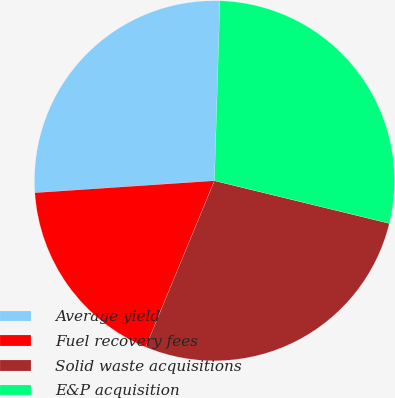<chart> <loc_0><loc_0><loc_500><loc_500><pie_chart><fcel>Average yield<fcel>Fuel recovery fees<fcel>Solid waste acquisitions<fcel>E&P acquisition<nl><fcel>26.55%<fcel>17.7%<fcel>27.43%<fcel>28.32%<nl></chart> 